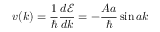<formula> <loc_0><loc_0><loc_500><loc_500>v ( k ) = { \frac { 1 } { } } { \frac { d { \mathcal { E } } } { d k } } = - { \frac { A a } { } } \sin { a k }</formula> 